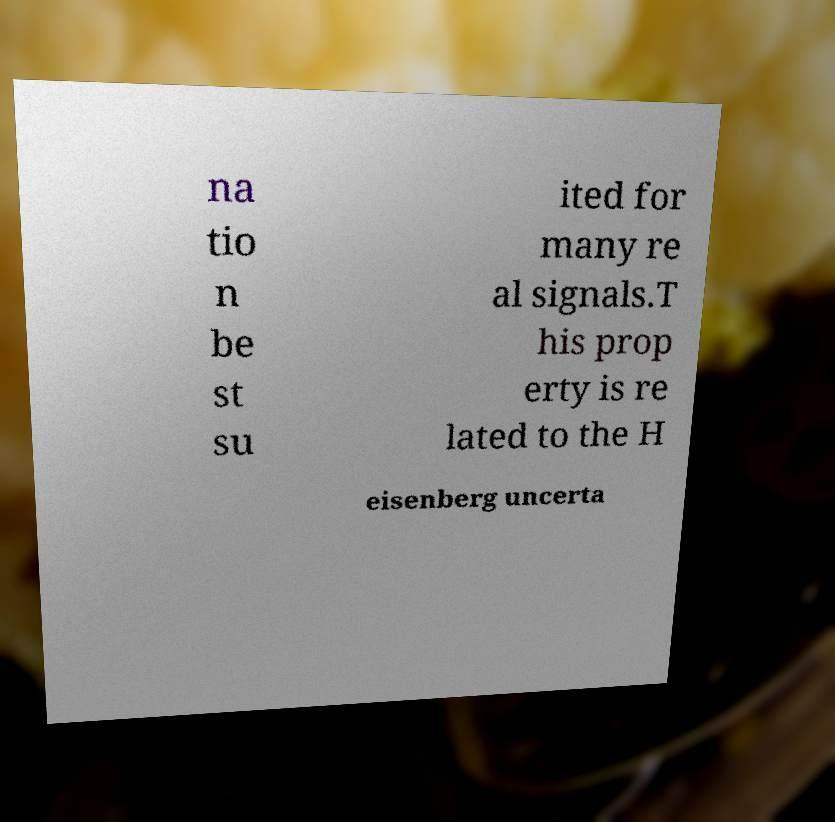There's text embedded in this image that I need extracted. Can you transcribe it verbatim? na tio n be st su ited for many re al signals.T his prop erty is re lated to the H eisenberg uncerta 